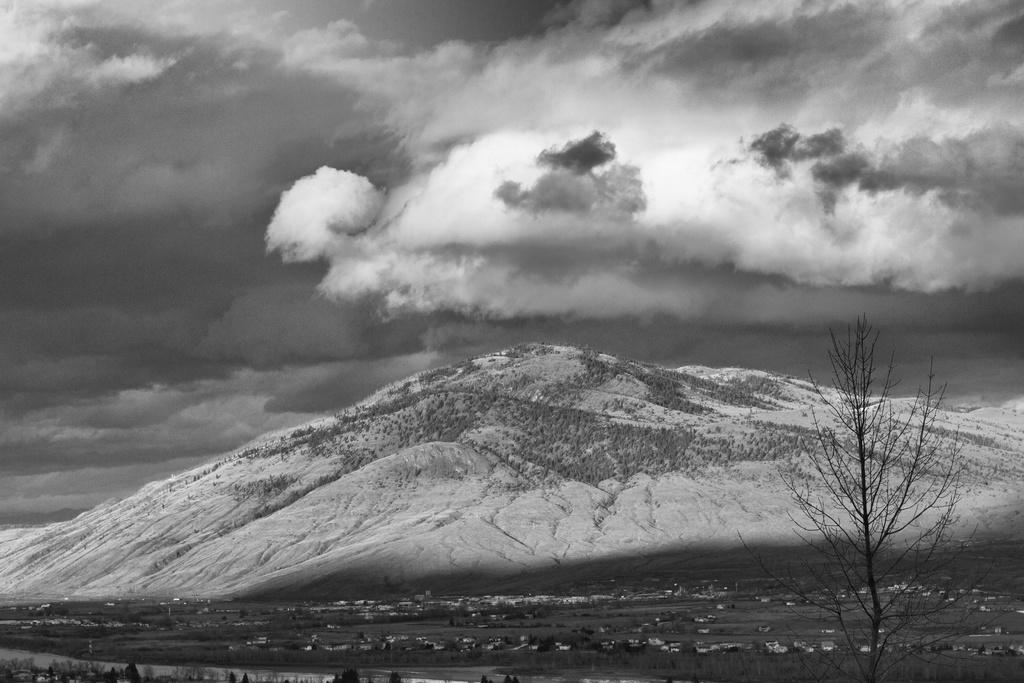What type of natural feature is present in the image? There is a mountain in the image. What type of man-made structures can be seen in the image? There are many buildings in the image. What type of vegetation is present in the image? There are trees in the image. What is the condition of the sky in the image? The sky is cloudy in the image. How many toy cars are parked near the trees in the image? There are no toy cars present in the image. What type of alarm is sounding near the mountain in the image? There is no alarm present in the image. 